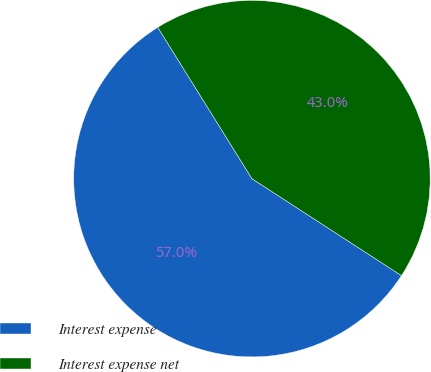<chart> <loc_0><loc_0><loc_500><loc_500><pie_chart><fcel>Interest expense<fcel>Interest expense net<nl><fcel>56.98%<fcel>43.02%<nl></chart> 